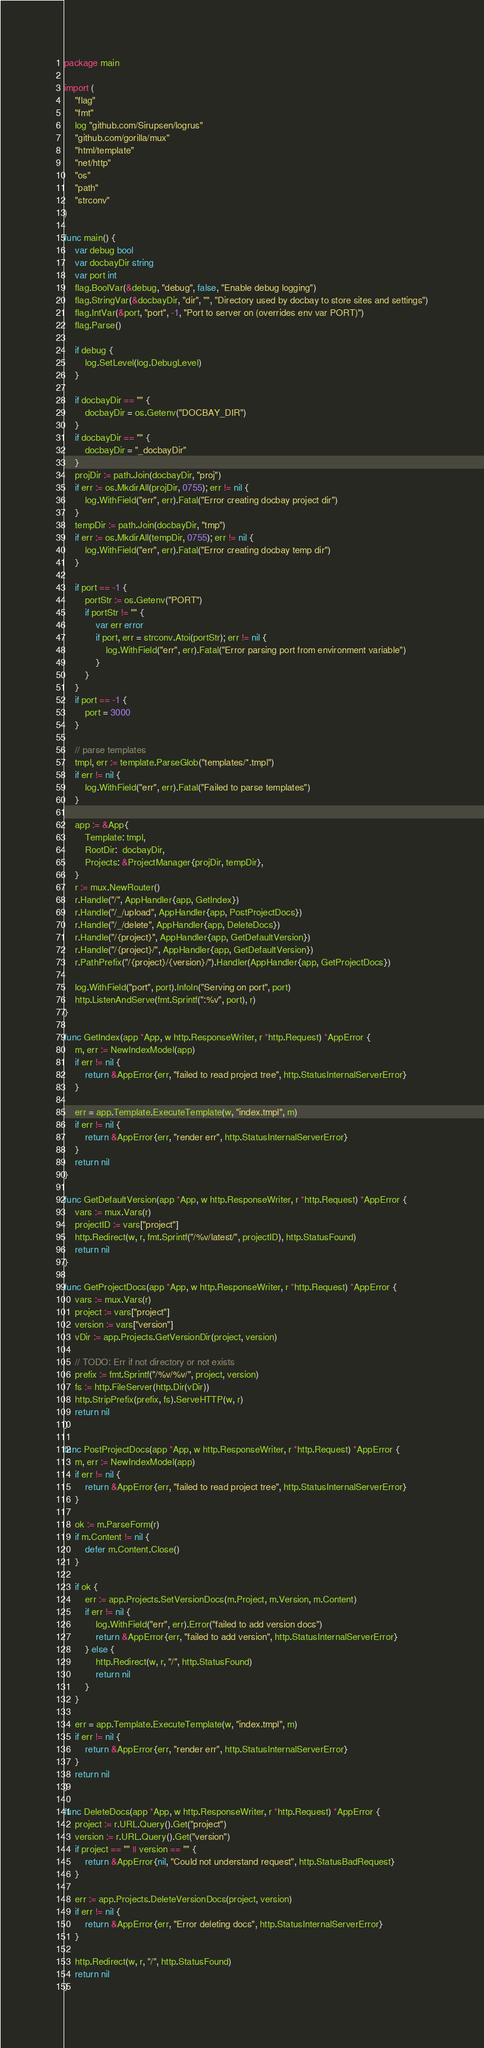Convert code to text. <code><loc_0><loc_0><loc_500><loc_500><_Go_>package main

import (
	"flag"
	"fmt"
	log "github.com/Sirupsen/logrus"
	"github.com/gorilla/mux"
	"html/template"
	"net/http"
	"os"
	"path"
	"strconv"
)

func main() {
	var debug bool
	var docbayDir string
	var port int
	flag.BoolVar(&debug, "debug", false, "Enable debug logging")
	flag.StringVar(&docbayDir, "dir", "", "Directory used by docbay to store sites and settings")
	flag.IntVar(&port, "port", -1, "Port to server on (overrides env var PORT)")
	flag.Parse()

	if debug {
		log.SetLevel(log.DebugLevel)
	}

	if docbayDir == "" {
		docbayDir = os.Getenv("DOCBAY_DIR")
	}
	if docbayDir == "" {
		docbayDir = "_docbayDir"
	}
	projDir := path.Join(docbayDir, "proj")
	if err := os.MkdirAll(projDir, 0755); err != nil {
		log.WithField("err", err).Fatal("Error creating docbay project dir")
	}
	tempDir := path.Join(docbayDir, "tmp")
	if err := os.MkdirAll(tempDir, 0755); err != nil {
		log.WithField("err", err).Fatal("Error creating docbay temp dir")
	}

	if port == -1 {
		portStr := os.Getenv("PORT")
		if portStr != "" {
			var err error
			if port, err = strconv.Atoi(portStr); err != nil {
				log.WithField("err", err).Fatal("Error parsing port from environment variable")
			}
		}
	}
	if port == -1 {
		port = 3000
	}

	// parse templates
	tmpl, err := template.ParseGlob("templates/*.tmpl")
	if err != nil {
		log.WithField("err", err).Fatal("Failed to parse templates")
	}

	app := &App{
		Template: tmpl,
		RootDir:  docbayDir,
		Projects: &ProjectManager{projDir, tempDir},
	}
	r := mux.NewRouter()
	r.Handle("/", AppHandler{app, GetIndex})
	r.Handle("/_/upload", AppHandler{app, PostProjectDocs})
	r.Handle("/_/delete", AppHandler{app, DeleteDocs})
	r.Handle("/{project}", AppHandler{app, GetDefaultVersion})
	r.Handle("/{project}/", AppHandler{app, GetDefaultVersion})
	r.PathPrefix("/{project}/{version}/").Handler(AppHandler{app, GetProjectDocs})

	log.WithField("port", port).Infoln("Serving on port", port)
	http.ListenAndServe(fmt.Sprintf(":%v", port), r)
}

func GetIndex(app *App, w http.ResponseWriter, r *http.Request) *AppError {
	m, err := NewIndexModel(app)
	if err != nil {
		return &AppError{err, "failed to read project tree", http.StatusInternalServerError}
	}

	err = app.Template.ExecuteTemplate(w, "index.tmpl", m)
	if err != nil {
		return &AppError{err, "render err", http.StatusInternalServerError}
	}
	return nil
}

func GetDefaultVersion(app *App, w http.ResponseWriter, r *http.Request) *AppError {
	vars := mux.Vars(r)
	projectID := vars["project"]
	http.Redirect(w, r, fmt.Sprintf("/%v/latest/", projectID), http.StatusFound)
	return nil
}

func GetProjectDocs(app *App, w http.ResponseWriter, r *http.Request) *AppError {
	vars := mux.Vars(r)
	project := vars["project"]
	version := vars["version"]
	vDir := app.Projects.GetVersionDir(project, version)

	// TODO: Err if not directory or not exists
	prefix := fmt.Sprintf("/%v/%v/", project, version)
	fs := http.FileServer(http.Dir(vDir))
	http.StripPrefix(prefix, fs).ServeHTTP(w, r)
	return nil
}

func PostProjectDocs(app *App, w http.ResponseWriter, r *http.Request) *AppError {
	m, err := NewIndexModel(app)
	if err != nil {
		return &AppError{err, "failed to read project tree", http.StatusInternalServerError}
	}

	ok := m.ParseForm(r)
	if m.Content != nil {
		defer m.Content.Close()
	}

	if ok {
		err := app.Projects.SetVersionDocs(m.Project, m.Version, m.Content)
		if err != nil {
			log.WithField("err", err).Error("failed to add version docs")
			return &AppError{err, "failed to add version", http.StatusInternalServerError}
		} else {
			http.Redirect(w, r, "/", http.StatusFound)
			return nil
		}
	}

	err = app.Template.ExecuteTemplate(w, "index.tmpl", m)
	if err != nil {
		return &AppError{err, "render err", http.StatusInternalServerError}
	}
	return nil
}

func DeleteDocs(app *App, w http.ResponseWriter, r *http.Request) *AppError {
	project := r.URL.Query().Get("project")
	version := r.URL.Query().Get("version")
	if project == "" || version == "" {
		return &AppError{nil, "Could not understand request", http.StatusBadRequest}
	}

	err := app.Projects.DeleteVersionDocs(project, version)
	if err != nil {
		return &AppError{err, "Error deleting docs", http.StatusInternalServerError}
	}

	http.Redirect(w, r, "/", http.StatusFound)
	return nil
}
</code> 